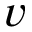Convert formula to latex. <formula><loc_0><loc_0><loc_500><loc_500>v</formula> 